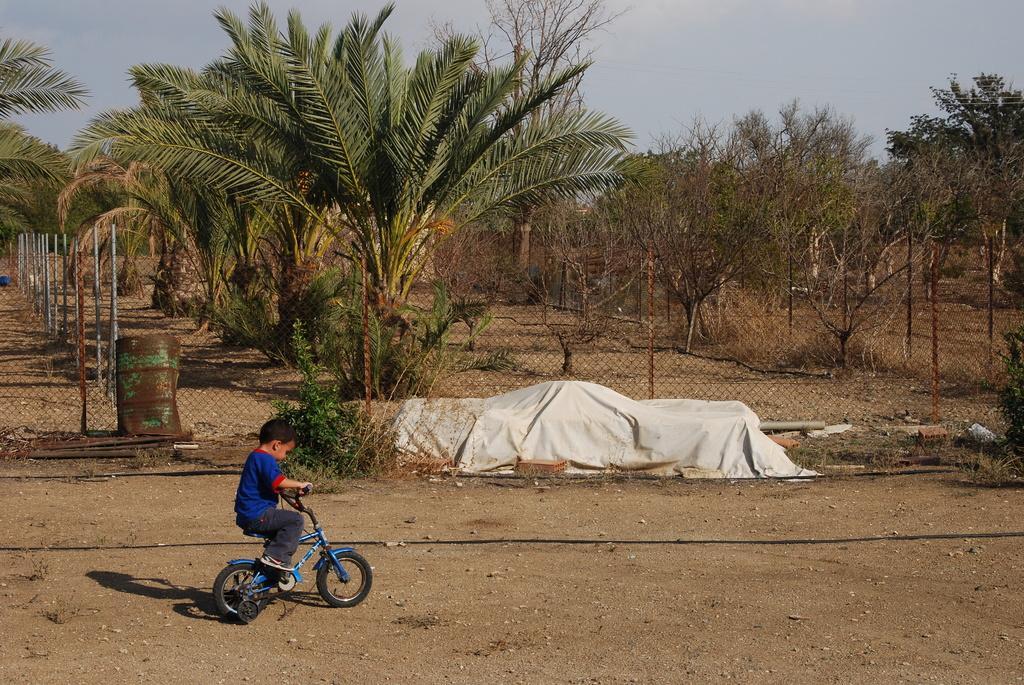In one or two sentences, can you explain what this image depicts? A boy is riding a cycle. And there is a white sheet over there. In the background there are trees, fencing with a mesh, sky. 